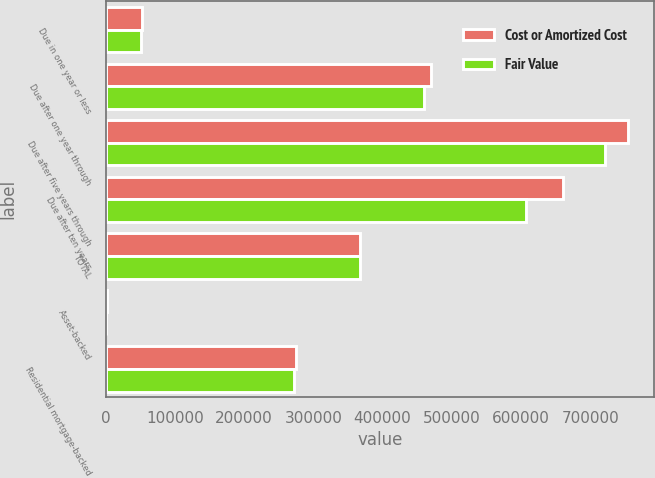Convert chart to OTSL. <chart><loc_0><loc_0><loc_500><loc_500><stacked_bar_chart><ecel><fcel>Due in one year or less<fcel>Due after one year through<fcel>Due after five years through<fcel>Due after ten years<fcel>TOTAL<fcel>Asset-backed<fcel>Residential mortgage-backed<nl><fcel>Cost or Amortized Cost<fcel>52077<fcel>469320<fcel>754402<fcel>660716<fcel>367553<fcel>1340<fcel>275176<nl><fcel>Fair Value<fcel>51667<fcel>459930<fcel>720632<fcel>607020<fcel>367553<fcel>1136<fcel>271767<nl></chart> 